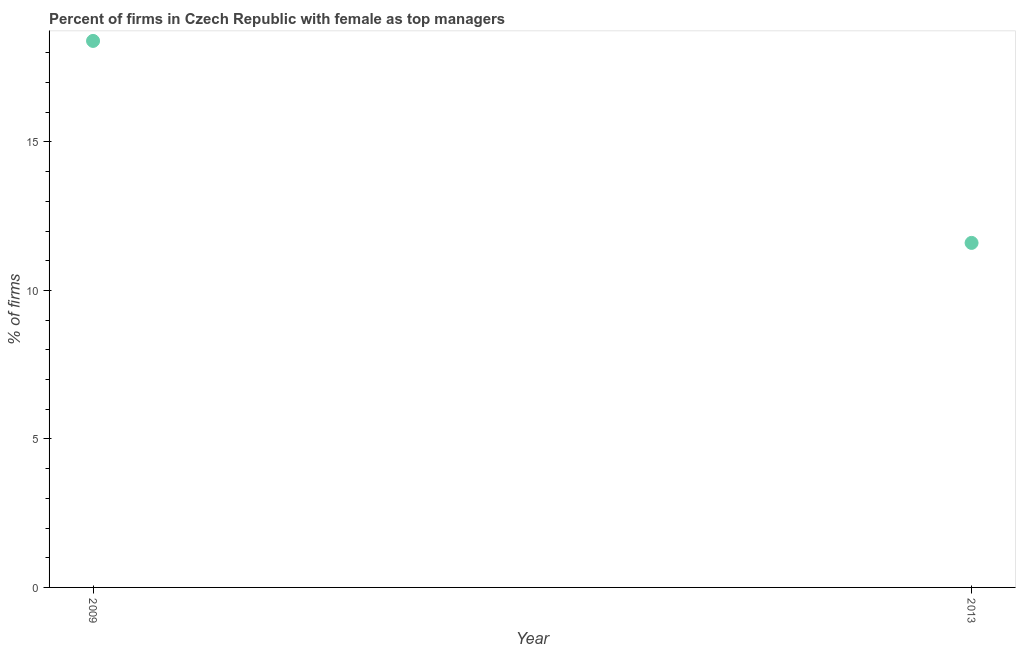Across all years, what is the maximum percentage of firms with female as top manager?
Give a very brief answer. 18.4. Across all years, what is the minimum percentage of firms with female as top manager?
Provide a short and direct response. 11.6. In which year was the percentage of firms with female as top manager maximum?
Offer a terse response. 2009. In which year was the percentage of firms with female as top manager minimum?
Offer a very short reply. 2013. What is the sum of the percentage of firms with female as top manager?
Give a very brief answer. 30. What is the difference between the percentage of firms with female as top manager in 2009 and 2013?
Offer a very short reply. 6.8. What is the average percentage of firms with female as top manager per year?
Make the answer very short. 15. What is the median percentage of firms with female as top manager?
Make the answer very short. 15. In how many years, is the percentage of firms with female as top manager greater than 12 %?
Provide a succinct answer. 1. Do a majority of the years between 2009 and 2013 (inclusive) have percentage of firms with female as top manager greater than 8 %?
Provide a succinct answer. Yes. What is the ratio of the percentage of firms with female as top manager in 2009 to that in 2013?
Make the answer very short. 1.59. Is the percentage of firms with female as top manager in 2009 less than that in 2013?
Offer a very short reply. No. Does the percentage of firms with female as top manager monotonically increase over the years?
Offer a very short reply. No. How many dotlines are there?
Give a very brief answer. 1. What is the difference between two consecutive major ticks on the Y-axis?
Make the answer very short. 5. Does the graph contain any zero values?
Your response must be concise. No. What is the title of the graph?
Ensure brevity in your answer.  Percent of firms in Czech Republic with female as top managers. What is the label or title of the X-axis?
Make the answer very short. Year. What is the label or title of the Y-axis?
Ensure brevity in your answer.  % of firms. What is the % of firms in 2013?
Your answer should be very brief. 11.6. What is the difference between the % of firms in 2009 and 2013?
Ensure brevity in your answer.  6.8. What is the ratio of the % of firms in 2009 to that in 2013?
Your response must be concise. 1.59. 